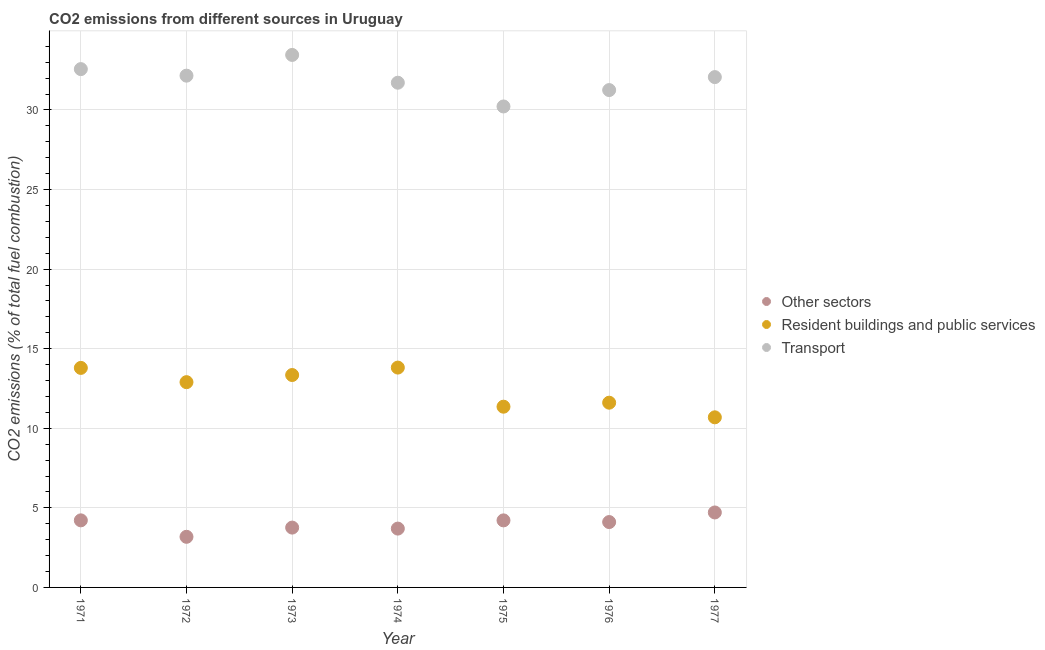What is the percentage of co2 emissions from transport in 1971?
Your response must be concise. 32.57. Across all years, what is the maximum percentage of co2 emissions from transport?
Give a very brief answer. 33.46. Across all years, what is the minimum percentage of co2 emissions from other sectors?
Offer a terse response. 3.18. In which year was the percentage of co2 emissions from transport maximum?
Ensure brevity in your answer.  1973. In which year was the percentage of co2 emissions from transport minimum?
Keep it short and to the point. 1975. What is the total percentage of co2 emissions from transport in the graph?
Provide a succinct answer. 223.43. What is the difference between the percentage of co2 emissions from other sectors in 1971 and that in 1977?
Offer a terse response. -0.5. What is the difference between the percentage of co2 emissions from other sectors in 1974 and the percentage of co2 emissions from transport in 1971?
Provide a short and direct response. -28.87. What is the average percentage of co2 emissions from other sectors per year?
Offer a very short reply. 3.98. In the year 1974, what is the difference between the percentage of co2 emissions from resident buildings and public services and percentage of co2 emissions from other sectors?
Offer a very short reply. 10.12. In how many years, is the percentage of co2 emissions from other sectors greater than 28 %?
Your answer should be compact. 0. What is the ratio of the percentage of co2 emissions from resident buildings and public services in 1971 to that in 1975?
Keep it short and to the point. 1.21. Is the percentage of co2 emissions from other sectors in 1972 less than that in 1976?
Give a very brief answer. Yes. What is the difference between the highest and the second highest percentage of co2 emissions from resident buildings and public services?
Provide a short and direct response. 0.02. What is the difference between the highest and the lowest percentage of co2 emissions from other sectors?
Your answer should be very brief. 1.53. Is the sum of the percentage of co2 emissions from resident buildings and public services in 1971 and 1972 greater than the maximum percentage of co2 emissions from other sectors across all years?
Your answer should be compact. Yes. Does the percentage of co2 emissions from other sectors monotonically increase over the years?
Offer a terse response. No. Is the percentage of co2 emissions from other sectors strictly greater than the percentage of co2 emissions from transport over the years?
Your response must be concise. No. Is the percentage of co2 emissions from resident buildings and public services strictly less than the percentage of co2 emissions from transport over the years?
Provide a succinct answer. Yes. How many dotlines are there?
Keep it short and to the point. 3. How many years are there in the graph?
Provide a succinct answer. 7. What is the difference between two consecutive major ticks on the Y-axis?
Provide a succinct answer. 5. Are the values on the major ticks of Y-axis written in scientific E-notation?
Your answer should be compact. No. Does the graph contain grids?
Make the answer very short. Yes. How many legend labels are there?
Your answer should be very brief. 3. What is the title of the graph?
Keep it short and to the point. CO2 emissions from different sources in Uruguay. What is the label or title of the X-axis?
Keep it short and to the point. Year. What is the label or title of the Y-axis?
Offer a very short reply. CO2 emissions (% of total fuel combustion). What is the CO2 emissions (% of total fuel combustion) of Other sectors in 1971?
Make the answer very short. 4.21. What is the CO2 emissions (% of total fuel combustion) in Resident buildings and public services in 1971?
Offer a very short reply. 13.79. What is the CO2 emissions (% of total fuel combustion) of Transport in 1971?
Provide a succinct answer. 32.57. What is the CO2 emissions (% of total fuel combustion) in Other sectors in 1972?
Your response must be concise. 3.18. What is the CO2 emissions (% of total fuel combustion) of Resident buildings and public services in 1972?
Keep it short and to the point. 12.9. What is the CO2 emissions (% of total fuel combustion) of Transport in 1972?
Your answer should be very brief. 32.16. What is the CO2 emissions (% of total fuel combustion) of Other sectors in 1973?
Keep it short and to the point. 3.76. What is the CO2 emissions (% of total fuel combustion) in Resident buildings and public services in 1973?
Your answer should be compact. 13.35. What is the CO2 emissions (% of total fuel combustion) in Transport in 1973?
Offer a terse response. 33.46. What is the CO2 emissions (% of total fuel combustion) in Other sectors in 1974?
Ensure brevity in your answer.  3.7. What is the CO2 emissions (% of total fuel combustion) in Resident buildings and public services in 1974?
Your answer should be very brief. 13.81. What is the CO2 emissions (% of total fuel combustion) of Transport in 1974?
Your response must be concise. 31.71. What is the CO2 emissions (% of total fuel combustion) of Other sectors in 1975?
Your answer should be very brief. 4.21. What is the CO2 emissions (% of total fuel combustion) of Resident buildings and public services in 1975?
Ensure brevity in your answer.  11.36. What is the CO2 emissions (% of total fuel combustion) in Transport in 1975?
Give a very brief answer. 30.22. What is the CO2 emissions (% of total fuel combustion) in Other sectors in 1976?
Make the answer very short. 4.11. What is the CO2 emissions (% of total fuel combustion) of Resident buildings and public services in 1976?
Your response must be concise. 11.61. What is the CO2 emissions (% of total fuel combustion) of Transport in 1976?
Ensure brevity in your answer.  31.25. What is the CO2 emissions (% of total fuel combustion) of Other sectors in 1977?
Make the answer very short. 4.71. What is the CO2 emissions (% of total fuel combustion) in Resident buildings and public services in 1977?
Give a very brief answer. 10.69. What is the CO2 emissions (% of total fuel combustion) of Transport in 1977?
Make the answer very short. 32.07. Across all years, what is the maximum CO2 emissions (% of total fuel combustion) in Other sectors?
Your response must be concise. 4.71. Across all years, what is the maximum CO2 emissions (% of total fuel combustion) in Resident buildings and public services?
Keep it short and to the point. 13.81. Across all years, what is the maximum CO2 emissions (% of total fuel combustion) in Transport?
Ensure brevity in your answer.  33.46. Across all years, what is the minimum CO2 emissions (% of total fuel combustion) of Other sectors?
Make the answer very short. 3.18. Across all years, what is the minimum CO2 emissions (% of total fuel combustion) in Resident buildings and public services?
Make the answer very short. 10.69. Across all years, what is the minimum CO2 emissions (% of total fuel combustion) of Transport?
Your answer should be compact. 30.22. What is the total CO2 emissions (% of total fuel combustion) in Other sectors in the graph?
Your response must be concise. 27.88. What is the total CO2 emissions (% of total fuel combustion) of Resident buildings and public services in the graph?
Offer a very short reply. 87.5. What is the total CO2 emissions (% of total fuel combustion) in Transport in the graph?
Your answer should be very brief. 223.43. What is the difference between the CO2 emissions (% of total fuel combustion) in Other sectors in 1971 and that in 1972?
Your response must be concise. 1.03. What is the difference between the CO2 emissions (% of total fuel combustion) in Resident buildings and public services in 1971 and that in 1972?
Provide a short and direct response. 0.9. What is the difference between the CO2 emissions (% of total fuel combustion) in Transport in 1971 and that in 1972?
Provide a short and direct response. 0.41. What is the difference between the CO2 emissions (% of total fuel combustion) in Other sectors in 1971 and that in 1973?
Your answer should be very brief. 0.46. What is the difference between the CO2 emissions (% of total fuel combustion) of Resident buildings and public services in 1971 and that in 1973?
Provide a short and direct response. 0.45. What is the difference between the CO2 emissions (% of total fuel combustion) in Transport in 1971 and that in 1973?
Your answer should be very brief. -0.89. What is the difference between the CO2 emissions (% of total fuel combustion) of Other sectors in 1971 and that in 1974?
Ensure brevity in your answer.  0.52. What is the difference between the CO2 emissions (% of total fuel combustion) of Resident buildings and public services in 1971 and that in 1974?
Your response must be concise. -0.02. What is the difference between the CO2 emissions (% of total fuel combustion) of Transport in 1971 and that in 1974?
Offer a terse response. 0.85. What is the difference between the CO2 emissions (% of total fuel combustion) of Other sectors in 1971 and that in 1975?
Give a very brief answer. 0. What is the difference between the CO2 emissions (% of total fuel combustion) in Resident buildings and public services in 1971 and that in 1975?
Provide a succinct answer. 2.44. What is the difference between the CO2 emissions (% of total fuel combustion) of Transport in 1971 and that in 1975?
Provide a succinct answer. 2.35. What is the difference between the CO2 emissions (% of total fuel combustion) of Other sectors in 1971 and that in 1976?
Offer a terse response. 0.11. What is the difference between the CO2 emissions (% of total fuel combustion) in Resident buildings and public services in 1971 and that in 1976?
Your answer should be compact. 2.19. What is the difference between the CO2 emissions (% of total fuel combustion) of Transport in 1971 and that in 1976?
Your answer should be very brief. 1.32. What is the difference between the CO2 emissions (% of total fuel combustion) of Other sectors in 1971 and that in 1977?
Ensure brevity in your answer.  -0.5. What is the difference between the CO2 emissions (% of total fuel combustion) in Resident buildings and public services in 1971 and that in 1977?
Offer a very short reply. 3.1. What is the difference between the CO2 emissions (% of total fuel combustion) of Transport in 1971 and that in 1977?
Your answer should be very brief. 0.5. What is the difference between the CO2 emissions (% of total fuel combustion) of Other sectors in 1972 and that in 1973?
Ensure brevity in your answer.  -0.58. What is the difference between the CO2 emissions (% of total fuel combustion) in Resident buildings and public services in 1972 and that in 1973?
Offer a terse response. -0.45. What is the difference between the CO2 emissions (% of total fuel combustion) in Transport in 1972 and that in 1973?
Your answer should be compact. -1.3. What is the difference between the CO2 emissions (% of total fuel combustion) in Other sectors in 1972 and that in 1974?
Your response must be concise. -0.52. What is the difference between the CO2 emissions (% of total fuel combustion) in Resident buildings and public services in 1972 and that in 1974?
Your answer should be compact. -0.92. What is the difference between the CO2 emissions (% of total fuel combustion) in Transport in 1972 and that in 1974?
Provide a short and direct response. 0.44. What is the difference between the CO2 emissions (% of total fuel combustion) of Other sectors in 1972 and that in 1975?
Provide a succinct answer. -1.03. What is the difference between the CO2 emissions (% of total fuel combustion) of Resident buildings and public services in 1972 and that in 1975?
Offer a terse response. 1.54. What is the difference between the CO2 emissions (% of total fuel combustion) in Transport in 1972 and that in 1975?
Your answer should be very brief. 1.94. What is the difference between the CO2 emissions (% of total fuel combustion) of Other sectors in 1972 and that in 1976?
Your answer should be very brief. -0.93. What is the difference between the CO2 emissions (% of total fuel combustion) of Resident buildings and public services in 1972 and that in 1976?
Provide a succinct answer. 1.29. What is the difference between the CO2 emissions (% of total fuel combustion) of Transport in 1972 and that in 1976?
Your response must be concise. 0.91. What is the difference between the CO2 emissions (% of total fuel combustion) of Other sectors in 1972 and that in 1977?
Give a very brief answer. -1.53. What is the difference between the CO2 emissions (% of total fuel combustion) of Resident buildings and public services in 1972 and that in 1977?
Keep it short and to the point. 2.21. What is the difference between the CO2 emissions (% of total fuel combustion) in Transport in 1972 and that in 1977?
Your response must be concise. 0.09. What is the difference between the CO2 emissions (% of total fuel combustion) of Other sectors in 1973 and that in 1974?
Offer a terse response. 0.06. What is the difference between the CO2 emissions (% of total fuel combustion) in Resident buildings and public services in 1973 and that in 1974?
Keep it short and to the point. -0.47. What is the difference between the CO2 emissions (% of total fuel combustion) in Transport in 1973 and that in 1974?
Provide a succinct answer. 1.75. What is the difference between the CO2 emissions (% of total fuel combustion) in Other sectors in 1973 and that in 1975?
Provide a succinct answer. -0.45. What is the difference between the CO2 emissions (% of total fuel combustion) in Resident buildings and public services in 1973 and that in 1975?
Your answer should be compact. 1.99. What is the difference between the CO2 emissions (% of total fuel combustion) of Transport in 1973 and that in 1975?
Your answer should be compact. 3.24. What is the difference between the CO2 emissions (% of total fuel combustion) of Other sectors in 1973 and that in 1976?
Ensure brevity in your answer.  -0.35. What is the difference between the CO2 emissions (% of total fuel combustion) in Resident buildings and public services in 1973 and that in 1976?
Give a very brief answer. 1.74. What is the difference between the CO2 emissions (% of total fuel combustion) in Transport in 1973 and that in 1976?
Give a very brief answer. 2.21. What is the difference between the CO2 emissions (% of total fuel combustion) in Other sectors in 1973 and that in 1977?
Offer a terse response. -0.95. What is the difference between the CO2 emissions (% of total fuel combustion) of Resident buildings and public services in 1973 and that in 1977?
Give a very brief answer. 2.66. What is the difference between the CO2 emissions (% of total fuel combustion) in Transport in 1973 and that in 1977?
Ensure brevity in your answer.  1.39. What is the difference between the CO2 emissions (% of total fuel combustion) of Other sectors in 1974 and that in 1975?
Offer a very short reply. -0.52. What is the difference between the CO2 emissions (% of total fuel combustion) of Resident buildings and public services in 1974 and that in 1975?
Keep it short and to the point. 2.46. What is the difference between the CO2 emissions (% of total fuel combustion) of Transport in 1974 and that in 1975?
Make the answer very short. 1.49. What is the difference between the CO2 emissions (% of total fuel combustion) of Other sectors in 1974 and that in 1976?
Make the answer very short. -0.41. What is the difference between the CO2 emissions (% of total fuel combustion) of Resident buildings and public services in 1974 and that in 1976?
Provide a short and direct response. 2.21. What is the difference between the CO2 emissions (% of total fuel combustion) of Transport in 1974 and that in 1976?
Your answer should be very brief. 0.46. What is the difference between the CO2 emissions (% of total fuel combustion) of Other sectors in 1974 and that in 1977?
Make the answer very short. -1.01. What is the difference between the CO2 emissions (% of total fuel combustion) in Resident buildings and public services in 1974 and that in 1977?
Your answer should be very brief. 3.12. What is the difference between the CO2 emissions (% of total fuel combustion) of Transport in 1974 and that in 1977?
Your answer should be very brief. -0.35. What is the difference between the CO2 emissions (% of total fuel combustion) in Other sectors in 1975 and that in 1976?
Offer a very short reply. 0.11. What is the difference between the CO2 emissions (% of total fuel combustion) of Resident buildings and public services in 1975 and that in 1976?
Keep it short and to the point. -0.25. What is the difference between the CO2 emissions (% of total fuel combustion) of Transport in 1975 and that in 1976?
Give a very brief answer. -1.03. What is the difference between the CO2 emissions (% of total fuel combustion) of Other sectors in 1975 and that in 1977?
Provide a succinct answer. -0.5. What is the difference between the CO2 emissions (% of total fuel combustion) in Resident buildings and public services in 1975 and that in 1977?
Provide a short and direct response. 0.67. What is the difference between the CO2 emissions (% of total fuel combustion) in Transport in 1975 and that in 1977?
Your answer should be compact. -1.85. What is the difference between the CO2 emissions (% of total fuel combustion) of Other sectors in 1976 and that in 1977?
Ensure brevity in your answer.  -0.6. What is the difference between the CO2 emissions (% of total fuel combustion) of Resident buildings and public services in 1976 and that in 1977?
Provide a succinct answer. 0.92. What is the difference between the CO2 emissions (% of total fuel combustion) of Transport in 1976 and that in 1977?
Offer a terse response. -0.82. What is the difference between the CO2 emissions (% of total fuel combustion) in Other sectors in 1971 and the CO2 emissions (% of total fuel combustion) in Resident buildings and public services in 1972?
Offer a terse response. -8.68. What is the difference between the CO2 emissions (% of total fuel combustion) of Other sectors in 1971 and the CO2 emissions (% of total fuel combustion) of Transport in 1972?
Provide a short and direct response. -27.94. What is the difference between the CO2 emissions (% of total fuel combustion) of Resident buildings and public services in 1971 and the CO2 emissions (% of total fuel combustion) of Transport in 1972?
Provide a succinct answer. -18.36. What is the difference between the CO2 emissions (% of total fuel combustion) of Other sectors in 1971 and the CO2 emissions (% of total fuel combustion) of Resident buildings and public services in 1973?
Your answer should be very brief. -9.13. What is the difference between the CO2 emissions (% of total fuel combustion) of Other sectors in 1971 and the CO2 emissions (% of total fuel combustion) of Transport in 1973?
Your answer should be compact. -29.24. What is the difference between the CO2 emissions (% of total fuel combustion) in Resident buildings and public services in 1971 and the CO2 emissions (% of total fuel combustion) in Transport in 1973?
Offer a very short reply. -19.67. What is the difference between the CO2 emissions (% of total fuel combustion) in Other sectors in 1971 and the CO2 emissions (% of total fuel combustion) in Resident buildings and public services in 1974?
Offer a very short reply. -9.6. What is the difference between the CO2 emissions (% of total fuel combustion) of Other sectors in 1971 and the CO2 emissions (% of total fuel combustion) of Transport in 1974?
Offer a very short reply. -27.5. What is the difference between the CO2 emissions (% of total fuel combustion) in Resident buildings and public services in 1971 and the CO2 emissions (% of total fuel combustion) in Transport in 1974?
Keep it short and to the point. -17.92. What is the difference between the CO2 emissions (% of total fuel combustion) of Other sectors in 1971 and the CO2 emissions (% of total fuel combustion) of Resident buildings and public services in 1975?
Ensure brevity in your answer.  -7.14. What is the difference between the CO2 emissions (% of total fuel combustion) of Other sectors in 1971 and the CO2 emissions (% of total fuel combustion) of Transport in 1975?
Your response must be concise. -26.01. What is the difference between the CO2 emissions (% of total fuel combustion) of Resident buildings and public services in 1971 and the CO2 emissions (% of total fuel combustion) of Transport in 1975?
Provide a succinct answer. -16.43. What is the difference between the CO2 emissions (% of total fuel combustion) in Other sectors in 1971 and the CO2 emissions (% of total fuel combustion) in Resident buildings and public services in 1976?
Provide a short and direct response. -7.39. What is the difference between the CO2 emissions (% of total fuel combustion) in Other sectors in 1971 and the CO2 emissions (% of total fuel combustion) in Transport in 1976?
Your response must be concise. -27.04. What is the difference between the CO2 emissions (% of total fuel combustion) in Resident buildings and public services in 1971 and the CO2 emissions (% of total fuel combustion) in Transport in 1976?
Make the answer very short. -17.46. What is the difference between the CO2 emissions (% of total fuel combustion) of Other sectors in 1971 and the CO2 emissions (% of total fuel combustion) of Resident buildings and public services in 1977?
Provide a short and direct response. -6.47. What is the difference between the CO2 emissions (% of total fuel combustion) of Other sectors in 1971 and the CO2 emissions (% of total fuel combustion) of Transport in 1977?
Keep it short and to the point. -27.85. What is the difference between the CO2 emissions (% of total fuel combustion) of Resident buildings and public services in 1971 and the CO2 emissions (% of total fuel combustion) of Transport in 1977?
Provide a succinct answer. -18.27. What is the difference between the CO2 emissions (% of total fuel combustion) in Other sectors in 1972 and the CO2 emissions (% of total fuel combustion) in Resident buildings and public services in 1973?
Offer a very short reply. -10.17. What is the difference between the CO2 emissions (% of total fuel combustion) in Other sectors in 1972 and the CO2 emissions (% of total fuel combustion) in Transport in 1973?
Make the answer very short. -30.28. What is the difference between the CO2 emissions (% of total fuel combustion) in Resident buildings and public services in 1972 and the CO2 emissions (% of total fuel combustion) in Transport in 1973?
Your answer should be compact. -20.56. What is the difference between the CO2 emissions (% of total fuel combustion) of Other sectors in 1972 and the CO2 emissions (% of total fuel combustion) of Resident buildings and public services in 1974?
Provide a succinct answer. -10.63. What is the difference between the CO2 emissions (% of total fuel combustion) in Other sectors in 1972 and the CO2 emissions (% of total fuel combustion) in Transport in 1974?
Your answer should be compact. -28.53. What is the difference between the CO2 emissions (% of total fuel combustion) of Resident buildings and public services in 1972 and the CO2 emissions (% of total fuel combustion) of Transport in 1974?
Offer a very short reply. -18.81. What is the difference between the CO2 emissions (% of total fuel combustion) in Other sectors in 1972 and the CO2 emissions (% of total fuel combustion) in Resident buildings and public services in 1975?
Give a very brief answer. -8.18. What is the difference between the CO2 emissions (% of total fuel combustion) in Other sectors in 1972 and the CO2 emissions (% of total fuel combustion) in Transport in 1975?
Give a very brief answer. -27.04. What is the difference between the CO2 emissions (% of total fuel combustion) of Resident buildings and public services in 1972 and the CO2 emissions (% of total fuel combustion) of Transport in 1975?
Give a very brief answer. -17.32. What is the difference between the CO2 emissions (% of total fuel combustion) of Other sectors in 1972 and the CO2 emissions (% of total fuel combustion) of Resident buildings and public services in 1976?
Ensure brevity in your answer.  -8.43. What is the difference between the CO2 emissions (% of total fuel combustion) of Other sectors in 1972 and the CO2 emissions (% of total fuel combustion) of Transport in 1976?
Provide a short and direct response. -28.07. What is the difference between the CO2 emissions (% of total fuel combustion) in Resident buildings and public services in 1972 and the CO2 emissions (% of total fuel combustion) in Transport in 1976?
Offer a very short reply. -18.35. What is the difference between the CO2 emissions (% of total fuel combustion) in Other sectors in 1972 and the CO2 emissions (% of total fuel combustion) in Resident buildings and public services in 1977?
Offer a very short reply. -7.51. What is the difference between the CO2 emissions (% of total fuel combustion) of Other sectors in 1972 and the CO2 emissions (% of total fuel combustion) of Transport in 1977?
Your answer should be compact. -28.89. What is the difference between the CO2 emissions (% of total fuel combustion) of Resident buildings and public services in 1972 and the CO2 emissions (% of total fuel combustion) of Transport in 1977?
Offer a very short reply. -19.17. What is the difference between the CO2 emissions (% of total fuel combustion) of Other sectors in 1973 and the CO2 emissions (% of total fuel combustion) of Resident buildings and public services in 1974?
Your response must be concise. -10.05. What is the difference between the CO2 emissions (% of total fuel combustion) of Other sectors in 1973 and the CO2 emissions (% of total fuel combustion) of Transport in 1974?
Provide a succinct answer. -27.95. What is the difference between the CO2 emissions (% of total fuel combustion) in Resident buildings and public services in 1973 and the CO2 emissions (% of total fuel combustion) in Transport in 1974?
Provide a short and direct response. -18.37. What is the difference between the CO2 emissions (% of total fuel combustion) in Other sectors in 1973 and the CO2 emissions (% of total fuel combustion) in Resident buildings and public services in 1975?
Keep it short and to the point. -7.6. What is the difference between the CO2 emissions (% of total fuel combustion) in Other sectors in 1973 and the CO2 emissions (% of total fuel combustion) in Transport in 1975?
Provide a short and direct response. -26.46. What is the difference between the CO2 emissions (% of total fuel combustion) of Resident buildings and public services in 1973 and the CO2 emissions (% of total fuel combustion) of Transport in 1975?
Provide a short and direct response. -16.87. What is the difference between the CO2 emissions (% of total fuel combustion) in Other sectors in 1973 and the CO2 emissions (% of total fuel combustion) in Resident buildings and public services in 1976?
Your answer should be compact. -7.85. What is the difference between the CO2 emissions (% of total fuel combustion) of Other sectors in 1973 and the CO2 emissions (% of total fuel combustion) of Transport in 1976?
Your response must be concise. -27.49. What is the difference between the CO2 emissions (% of total fuel combustion) in Resident buildings and public services in 1973 and the CO2 emissions (% of total fuel combustion) in Transport in 1976?
Your answer should be very brief. -17.9. What is the difference between the CO2 emissions (% of total fuel combustion) of Other sectors in 1973 and the CO2 emissions (% of total fuel combustion) of Resident buildings and public services in 1977?
Offer a terse response. -6.93. What is the difference between the CO2 emissions (% of total fuel combustion) in Other sectors in 1973 and the CO2 emissions (% of total fuel combustion) in Transport in 1977?
Offer a very short reply. -28.31. What is the difference between the CO2 emissions (% of total fuel combustion) in Resident buildings and public services in 1973 and the CO2 emissions (% of total fuel combustion) in Transport in 1977?
Give a very brief answer. -18.72. What is the difference between the CO2 emissions (% of total fuel combustion) in Other sectors in 1974 and the CO2 emissions (% of total fuel combustion) in Resident buildings and public services in 1975?
Make the answer very short. -7.66. What is the difference between the CO2 emissions (% of total fuel combustion) in Other sectors in 1974 and the CO2 emissions (% of total fuel combustion) in Transport in 1975?
Keep it short and to the point. -26.52. What is the difference between the CO2 emissions (% of total fuel combustion) of Resident buildings and public services in 1974 and the CO2 emissions (% of total fuel combustion) of Transport in 1975?
Ensure brevity in your answer.  -16.41. What is the difference between the CO2 emissions (% of total fuel combustion) of Other sectors in 1974 and the CO2 emissions (% of total fuel combustion) of Resident buildings and public services in 1976?
Provide a short and direct response. -7.91. What is the difference between the CO2 emissions (% of total fuel combustion) in Other sectors in 1974 and the CO2 emissions (% of total fuel combustion) in Transport in 1976?
Make the answer very short. -27.55. What is the difference between the CO2 emissions (% of total fuel combustion) in Resident buildings and public services in 1974 and the CO2 emissions (% of total fuel combustion) in Transport in 1976?
Provide a succinct answer. -17.44. What is the difference between the CO2 emissions (% of total fuel combustion) of Other sectors in 1974 and the CO2 emissions (% of total fuel combustion) of Resident buildings and public services in 1977?
Give a very brief answer. -6.99. What is the difference between the CO2 emissions (% of total fuel combustion) in Other sectors in 1974 and the CO2 emissions (% of total fuel combustion) in Transport in 1977?
Provide a succinct answer. -28.37. What is the difference between the CO2 emissions (% of total fuel combustion) in Resident buildings and public services in 1974 and the CO2 emissions (% of total fuel combustion) in Transport in 1977?
Keep it short and to the point. -18.25. What is the difference between the CO2 emissions (% of total fuel combustion) of Other sectors in 1975 and the CO2 emissions (% of total fuel combustion) of Resident buildings and public services in 1976?
Offer a very short reply. -7.39. What is the difference between the CO2 emissions (% of total fuel combustion) of Other sectors in 1975 and the CO2 emissions (% of total fuel combustion) of Transport in 1976?
Give a very brief answer. -27.04. What is the difference between the CO2 emissions (% of total fuel combustion) of Resident buildings and public services in 1975 and the CO2 emissions (% of total fuel combustion) of Transport in 1976?
Offer a very short reply. -19.89. What is the difference between the CO2 emissions (% of total fuel combustion) in Other sectors in 1975 and the CO2 emissions (% of total fuel combustion) in Resident buildings and public services in 1977?
Your answer should be very brief. -6.48. What is the difference between the CO2 emissions (% of total fuel combustion) in Other sectors in 1975 and the CO2 emissions (% of total fuel combustion) in Transport in 1977?
Your answer should be very brief. -27.85. What is the difference between the CO2 emissions (% of total fuel combustion) in Resident buildings and public services in 1975 and the CO2 emissions (% of total fuel combustion) in Transport in 1977?
Offer a terse response. -20.71. What is the difference between the CO2 emissions (% of total fuel combustion) of Other sectors in 1976 and the CO2 emissions (% of total fuel combustion) of Resident buildings and public services in 1977?
Your answer should be very brief. -6.58. What is the difference between the CO2 emissions (% of total fuel combustion) of Other sectors in 1976 and the CO2 emissions (% of total fuel combustion) of Transport in 1977?
Ensure brevity in your answer.  -27.96. What is the difference between the CO2 emissions (% of total fuel combustion) in Resident buildings and public services in 1976 and the CO2 emissions (% of total fuel combustion) in Transport in 1977?
Give a very brief answer. -20.46. What is the average CO2 emissions (% of total fuel combustion) of Other sectors per year?
Make the answer very short. 3.98. What is the average CO2 emissions (% of total fuel combustion) in Resident buildings and public services per year?
Your response must be concise. 12.5. What is the average CO2 emissions (% of total fuel combustion) in Transport per year?
Ensure brevity in your answer.  31.92. In the year 1971, what is the difference between the CO2 emissions (% of total fuel combustion) of Other sectors and CO2 emissions (% of total fuel combustion) of Resident buildings and public services?
Your answer should be very brief. -9.58. In the year 1971, what is the difference between the CO2 emissions (% of total fuel combustion) of Other sectors and CO2 emissions (% of total fuel combustion) of Transport?
Keep it short and to the point. -28.35. In the year 1971, what is the difference between the CO2 emissions (% of total fuel combustion) of Resident buildings and public services and CO2 emissions (% of total fuel combustion) of Transport?
Give a very brief answer. -18.77. In the year 1972, what is the difference between the CO2 emissions (% of total fuel combustion) of Other sectors and CO2 emissions (% of total fuel combustion) of Resident buildings and public services?
Your answer should be very brief. -9.72. In the year 1972, what is the difference between the CO2 emissions (% of total fuel combustion) of Other sectors and CO2 emissions (% of total fuel combustion) of Transport?
Ensure brevity in your answer.  -28.98. In the year 1972, what is the difference between the CO2 emissions (% of total fuel combustion) in Resident buildings and public services and CO2 emissions (% of total fuel combustion) in Transport?
Your answer should be compact. -19.26. In the year 1973, what is the difference between the CO2 emissions (% of total fuel combustion) of Other sectors and CO2 emissions (% of total fuel combustion) of Resident buildings and public services?
Your response must be concise. -9.59. In the year 1973, what is the difference between the CO2 emissions (% of total fuel combustion) in Other sectors and CO2 emissions (% of total fuel combustion) in Transport?
Keep it short and to the point. -29.7. In the year 1973, what is the difference between the CO2 emissions (% of total fuel combustion) of Resident buildings and public services and CO2 emissions (% of total fuel combustion) of Transport?
Your answer should be compact. -20.11. In the year 1974, what is the difference between the CO2 emissions (% of total fuel combustion) of Other sectors and CO2 emissions (% of total fuel combustion) of Resident buildings and public services?
Provide a short and direct response. -10.12. In the year 1974, what is the difference between the CO2 emissions (% of total fuel combustion) in Other sectors and CO2 emissions (% of total fuel combustion) in Transport?
Offer a very short reply. -28.02. In the year 1974, what is the difference between the CO2 emissions (% of total fuel combustion) of Resident buildings and public services and CO2 emissions (% of total fuel combustion) of Transport?
Give a very brief answer. -17.9. In the year 1975, what is the difference between the CO2 emissions (% of total fuel combustion) of Other sectors and CO2 emissions (% of total fuel combustion) of Resident buildings and public services?
Keep it short and to the point. -7.14. In the year 1975, what is the difference between the CO2 emissions (% of total fuel combustion) in Other sectors and CO2 emissions (% of total fuel combustion) in Transport?
Provide a succinct answer. -26.01. In the year 1975, what is the difference between the CO2 emissions (% of total fuel combustion) of Resident buildings and public services and CO2 emissions (% of total fuel combustion) of Transport?
Your answer should be compact. -18.86. In the year 1976, what is the difference between the CO2 emissions (% of total fuel combustion) in Other sectors and CO2 emissions (% of total fuel combustion) in Resident buildings and public services?
Offer a very short reply. -7.5. In the year 1976, what is the difference between the CO2 emissions (% of total fuel combustion) in Other sectors and CO2 emissions (% of total fuel combustion) in Transport?
Give a very brief answer. -27.14. In the year 1976, what is the difference between the CO2 emissions (% of total fuel combustion) in Resident buildings and public services and CO2 emissions (% of total fuel combustion) in Transport?
Provide a short and direct response. -19.64. In the year 1977, what is the difference between the CO2 emissions (% of total fuel combustion) in Other sectors and CO2 emissions (% of total fuel combustion) in Resident buildings and public services?
Provide a succinct answer. -5.98. In the year 1977, what is the difference between the CO2 emissions (% of total fuel combustion) in Other sectors and CO2 emissions (% of total fuel combustion) in Transport?
Keep it short and to the point. -27.36. In the year 1977, what is the difference between the CO2 emissions (% of total fuel combustion) of Resident buildings and public services and CO2 emissions (% of total fuel combustion) of Transport?
Provide a succinct answer. -21.38. What is the ratio of the CO2 emissions (% of total fuel combustion) in Other sectors in 1971 to that in 1972?
Give a very brief answer. 1.33. What is the ratio of the CO2 emissions (% of total fuel combustion) in Resident buildings and public services in 1971 to that in 1972?
Ensure brevity in your answer.  1.07. What is the ratio of the CO2 emissions (% of total fuel combustion) of Transport in 1971 to that in 1972?
Offer a terse response. 1.01. What is the ratio of the CO2 emissions (% of total fuel combustion) of Other sectors in 1971 to that in 1973?
Give a very brief answer. 1.12. What is the ratio of the CO2 emissions (% of total fuel combustion) in Resident buildings and public services in 1971 to that in 1973?
Your answer should be very brief. 1.03. What is the ratio of the CO2 emissions (% of total fuel combustion) of Transport in 1971 to that in 1973?
Offer a very short reply. 0.97. What is the ratio of the CO2 emissions (% of total fuel combustion) of Other sectors in 1971 to that in 1974?
Give a very brief answer. 1.14. What is the ratio of the CO2 emissions (% of total fuel combustion) of Other sectors in 1971 to that in 1975?
Keep it short and to the point. 1. What is the ratio of the CO2 emissions (% of total fuel combustion) in Resident buildings and public services in 1971 to that in 1975?
Provide a short and direct response. 1.21. What is the ratio of the CO2 emissions (% of total fuel combustion) of Transport in 1971 to that in 1975?
Your response must be concise. 1.08. What is the ratio of the CO2 emissions (% of total fuel combustion) in Other sectors in 1971 to that in 1976?
Offer a terse response. 1.03. What is the ratio of the CO2 emissions (% of total fuel combustion) of Resident buildings and public services in 1971 to that in 1976?
Make the answer very short. 1.19. What is the ratio of the CO2 emissions (% of total fuel combustion) of Transport in 1971 to that in 1976?
Keep it short and to the point. 1.04. What is the ratio of the CO2 emissions (% of total fuel combustion) of Other sectors in 1971 to that in 1977?
Offer a very short reply. 0.89. What is the ratio of the CO2 emissions (% of total fuel combustion) in Resident buildings and public services in 1971 to that in 1977?
Give a very brief answer. 1.29. What is the ratio of the CO2 emissions (% of total fuel combustion) of Transport in 1971 to that in 1977?
Offer a terse response. 1.02. What is the ratio of the CO2 emissions (% of total fuel combustion) in Other sectors in 1972 to that in 1973?
Your answer should be very brief. 0.85. What is the ratio of the CO2 emissions (% of total fuel combustion) in Resident buildings and public services in 1972 to that in 1973?
Provide a succinct answer. 0.97. What is the ratio of the CO2 emissions (% of total fuel combustion) of Transport in 1972 to that in 1973?
Your answer should be compact. 0.96. What is the ratio of the CO2 emissions (% of total fuel combustion) of Other sectors in 1972 to that in 1974?
Keep it short and to the point. 0.86. What is the ratio of the CO2 emissions (% of total fuel combustion) of Resident buildings and public services in 1972 to that in 1974?
Your answer should be compact. 0.93. What is the ratio of the CO2 emissions (% of total fuel combustion) in Transport in 1972 to that in 1974?
Your response must be concise. 1.01. What is the ratio of the CO2 emissions (% of total fuel combustion) of Other sectors in 1972 to that in 1975?
Provide a succinct answer. 0.76. What is the ratio of the CO2 emissions (% of total fuel combustion) of Resident buildings and public services in 1972 to that in 1975?
Provide a short and direct response. 1.14. What is the ratio of the CO2 emissions (% of total fuel combustion) of Transport in 1972 to that in 1975?
Offer a terse response. 1.06. What is the ratio of the CO2 emissions (% of total fuel combustion) in Other sectors in 1972 to that in 1976?
Provide a succinct answer. 0.77. What is the ratio of the CO2 emissions (% of total fuel combustion) in Resident buildings and public services in 1972 to that in 1976?
Make the answer very short. 1.11. What is the ratio of the CO2 emissions (% of total fuel combustion) of Transport in 1972 to that in 1976?
Provide a succinct answer. 1.03. What is the ratio of the CO2 emissions (% of total fuel combustion) of Other sectors in 1972 to that in 1977?
Provide a short and direct response. 0.68. What is the ratio of the CO2 emissions (% of total fuel combustion) in Resident buildings and public services in 1972 to that in 1977?
Keep it short and to the point. 1.21. What is the ratio of the CO2 emissions (% of total fuel combustion) of Transport in 1972 to that in 1977?
Offer a very short reply. 1. What is the ratio of the CO2 emissions (% of total fuel combustion) in Other sectors in 1973 to that in 1974?
Your answer should be compact. 1.02. What is the ratio of the CO2 emissions (% of total fuel combustion) of Resident buildings and public services in 1973 to that in 1974?
Keep it short and to the point. 0.97. What is the ratio of the CO2 emissions (% of total fuel combustion) in Transport in 1973 to that in 1974?
Make the answer very short. 1.06. What is the ratio of the CO2 emissions (% of total fuel combustion) in Other sectors in 1973 to that in 1975?
Keep it short and to the point. 0.89. What is the ratio of the CO2 emissions (% of total fuel combustion) of Resident buildings and public services in 1973 to that in 1975?
Offer a terse response. 1.18. What is the ratio of the CO2 emissions (% of total fuel combustion) in Transport in 1973 to that in 1975?
Give a very brief answer. 1.11. What is the ratio of the CO2 emissions (% of total fuel combustion) of Other sectors in 1973 to that in 1976?
Your answer should be compact. 0.92. What is the ratio of the CO2 emissions (% of total fuel combustion) of Resident buildings and public services in 1973 to that in 1976?
Keep it short and to the point. 1.15. What is the ratio of the CO2 emissions (% of total fuel combustion) of Transport in 1973 to that in 1976?
Ensure brevity in your answer.  1.07. What is the ratio of the CO2 emissions (% of total fuel combustion) of Other sectors in 1973 to that in 1977?
Your response must be concise. 0.8. What is the ratio of the CO2 emissions (% of total fuel combustion) in Resident buildings and public services in 1973 to that in 1977?
Give a very brief answer. 1.25. What is the ratio of the CO2 emissions (% of total fuel combustion) of Transport in 1973 to that in 1977?
Your answer should be compact. 1.04. What is the ratio of the CO2 emissions (% of total fuel combustion) of Other sectors in 1974 to that in 1975?
Provide a short and direct response. 0.88. What is the ratio of the CO2 emissions (% of total fuel combustion) in Resident buildings and public services in 1974 to that in 1975?
Offer a very short reply. 1.22. What is the ratio of the CO2 emissions (% of total fuel combustion) in Transport in 1974 to that in 1975?
Keep it short and to the point. 1.05. What is the ratio of the CO2 emissions (% of total fuel combustion) in Other sectors in 1974 to that in 1976?
Keep it short and to the point. 0.9. What is the ratio of the CO2 emissions (% of total fuel combustion) in Resident buildings and public services in 1974 to that in 1976?
Offer a very short reply. 1.19. What is the ratio of the CO2 emissions (% of total fuel combustion) in Transport in 1974 to that in 1976?
Keep it short and to the point. 1.01. What is the ratio of the CO2 emissions (% of total fuel combustion) in Other sectors in 1974 to that in 1977?
Provide a succinct answer. 0.78. What is the ratio of the CO2 emissions (% of total fuel combustion) of Resident buildings and public services in 1974 to that in 1977?
Give a very brief answer. 1.29. What is the ratio of the CO2 emissions (% of total fuel combustion) of Transport in 1974 to that in 1977?
Ensure brevity in your answer.  0.99. What is the ratio of the CO2 emissions (% of total fuel combustion) in Other sectors in 1975 to that in 1976?
Your answer should be compact. 1.03. What is the ratio of the CO2 emissions (% of total fuel combustion) in Resident buildings and public services in 1975 to that in 1976?
Ensure brevity in your answer.  0.98. What is the ratio of the CO2 emissions (% of total fuel combustion) in Transport in 1975 to that in 1976?
Keep it short and to the point. 0.97. What is the ratio of the CO2 emissions (% of total fuel combustion) of Other sectors in 1975 to that in 1977?
Provide a short and direct response. 0.89. What is the ratio of the CO2 emissions (% of total fuel combustion) in Resident buildings and public services in 1975 to that in 1977?
Your answer should be compact. 1.06. What is the ratio of the CO2 emissions (% of total fuel combustion) in Transport in 1975 to that in 1977?
Your answer should be very brief. 0.94. What is the ratio of the CO2 emissions (% of total fuel combustion) in Other sectors in 1976 to that in 1977?
Offer a very short reply. 0.87. What is the ratio of the CO2 emissions (% of total fuel combustion) in Resident buildings and public services in 1976 to that in 1977?
Your answer should be compact. 1.09. What is the ratio of the CO2 emissions (% of total fuel combustion) in Transport in 1976 to that in 1977?
Your response must be concise. 0.97. What is the difference between the highest and the second highest CO2 emissions (% of total fuel combustion) in Other sectors?
Your answer should be very brief. 0.5. What is the difference between the highest and the second highest CO2 emissions (% of total fuel combustion) of Resident buildings and public services?
Your answer should be very brief. 0.02. What is the difference between the highest and the second highest CO2 emissions (% of total fuel combustion) of Transport?
Your response must be concise. 0.89. What is the difference between the highest and the lowest CO2 emissions (% of total fuel combustion) of Other sectors?
Keep it short and to the point. 1.53. What is the difference between the highest and the lowest CO2 emissions (% of total fuel combustion) of Resident buildings and public services?
Provide a short and direct response. 3.12. What is the difference between the highest and the lowest CO2 emissions (% of total fuel combustion) of Transport?
Keep it short and to the point. 3.24. 